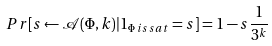Convert formula to latex. <formula><loc_0><loc_0><loc_500><loc_500>P r [ s \leftarrow \mathcal { A } ( \Phi , k ) | 1 _ { \Phi \, i s \, s a t } = s ] = 1 - s \frac { 1 } { 3 ^ { k } }</formula> 